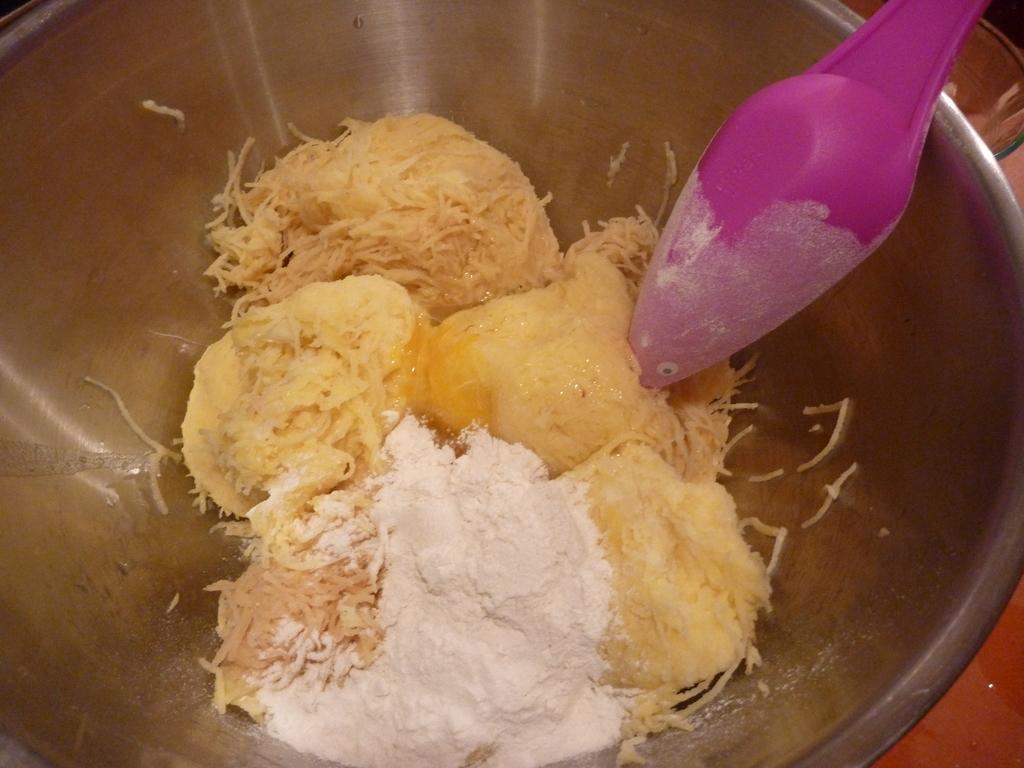Please provide a concise description of this image. In this image there is a bowl, having some food and spoon in it. Bowl is kept on a table. 